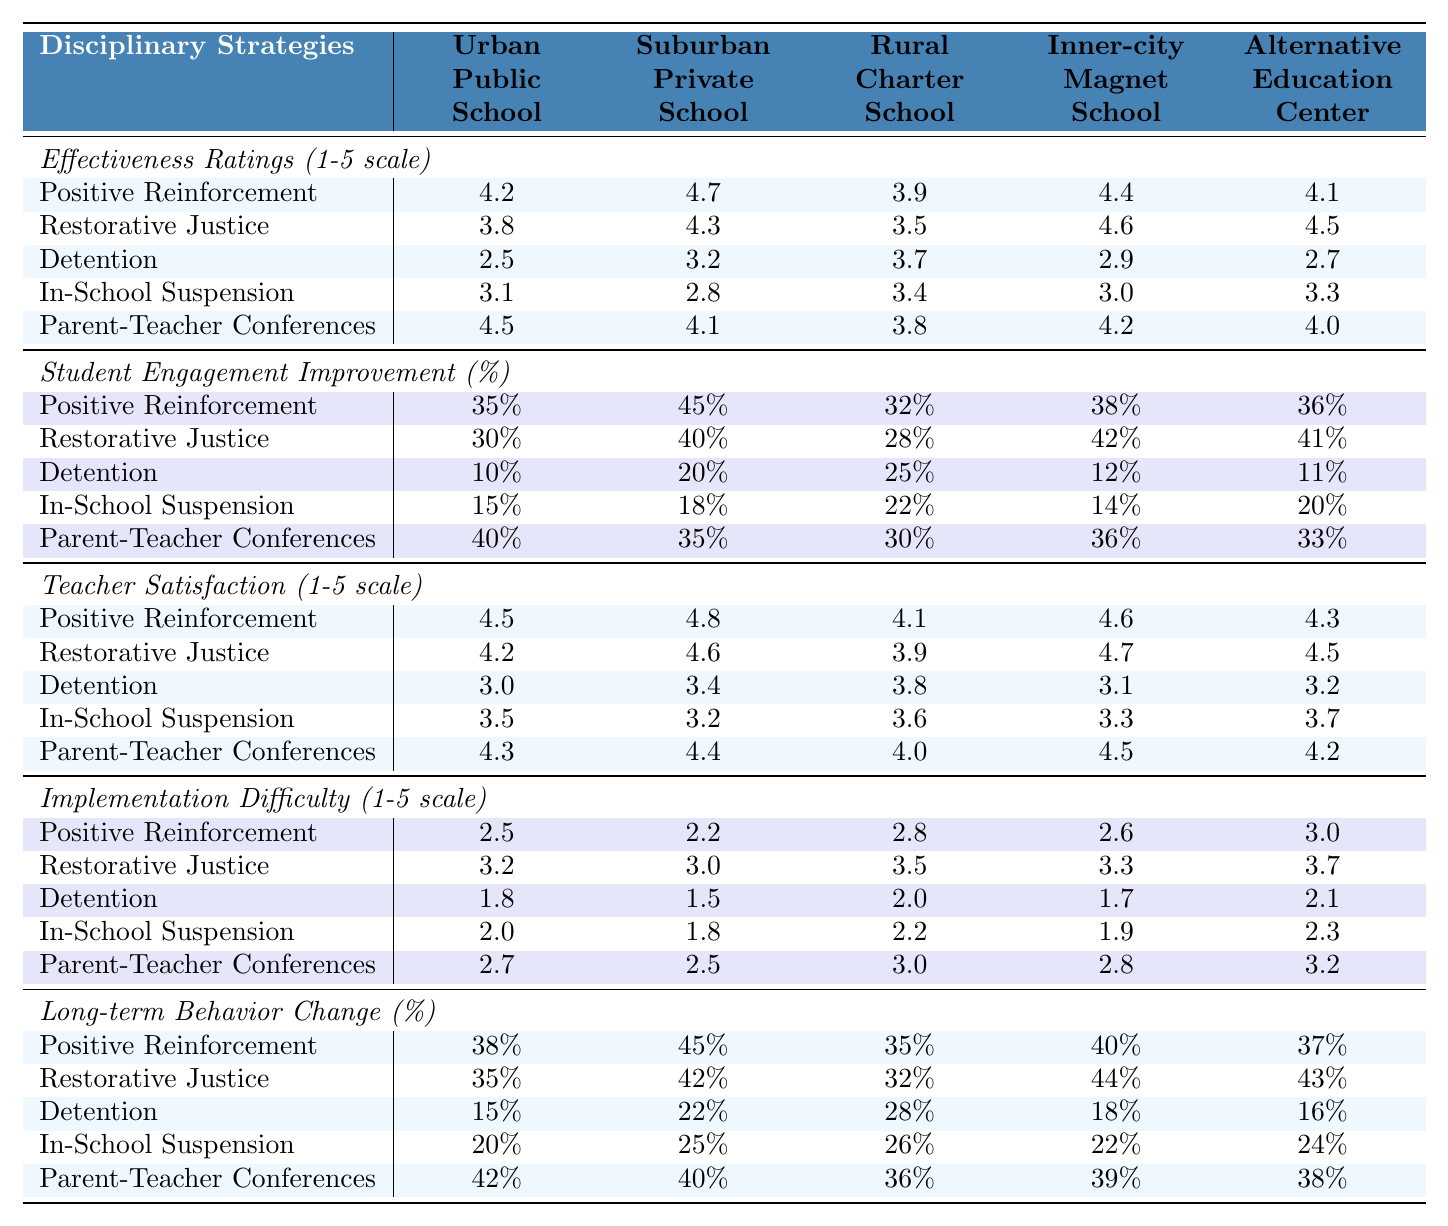What is the effectiveness rating of Restorative Justice in the Suburban Private School? According to the table, the effectiveness rating for Restorative Justice in the Suburban Private School is provided as a specific value: 4.3.
Answer: 4.3 Which disciplinary strategy has the highest effectiveness rating in the Urban Public School? The highest effectiveness rating in the Urban Public School is for Positive Reinforcement, which has a rating of 4.2.
Answer: Positive Reinforcement What is the percentage improvement in student engagement for Detention in the Rural Charter School? The table shows that the percentage improvement in student engagement for Detention in the Rural Charter School is 25%.
Answer: 25% Which school setting showed the lowest effectiveness rating for Detention among all the settings? The table reveals that the lowest effectiveness rating for Detention is 2.5, which corresponds to the Urban Public School.
Answer: Urban Public School What is the average teacher satisfaction rating for Parent-Teacher Conferences across all school settings? To calculate the average, add the ratings for Parent-Teacher Conferences across all five settings: (4.5 + 4.1 + 4.0 + 4.5 + 4.2) = 21.3. Then divide by 5, which gives 21.3/5 = 4.26.
Answer: 4.26 In the Inner-city Magnet School, which disciplinary strategy shows the lowest student engagement improvement? By reviewing the data for the Inner-city Magnet School, Detention shows the lowest student engagement improvement at 12%.
Answer: Detention What is the difference in effectiveness ratings between Positive Reinforcement and In-School Suspension in the Suburban Private School? In the Suburban Private School, the rating for Positive Reinforcement is 4.7 and for In-School Suspension is 2.8. The difference is 4.7 - 2.8 = 1.9.
Answer: 1.9 Which school setting has the highest percentage improvement in student engagement for Restorative Justice? The table indicates that the highest percentage improvement for Restorative Justice is in the Suburban Private School at 40%.
Answer: Suburban Private School If we look at the long-term behavior change percentage for Positive Reinforcement in the Urban Public School, what is it? The table indicates that the long-term behavior change percentage for Positive Reinforcement in the Urban Public School is 38%.
Answer: 38% Which disciplinary strategy is the easiest to implement in the Rural Charter School? The implementation difficulty values for the Rural Charter School show that Detention has the lowest difficulty rating of 2.0, making it the easiest to implement.
Answer: Detention 